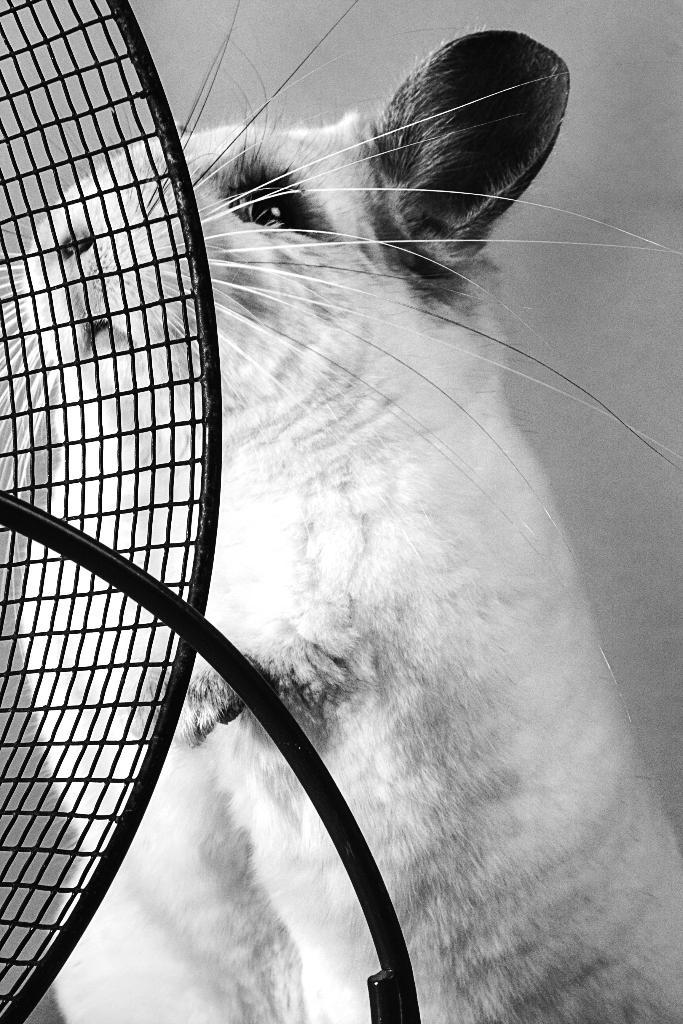What type of animal is in the image? There is an animal in the image, but the specific type cannot be determined from the provided facts. What is the metal object in front of the animal? The metal object in front of the animal cannot be described in detail based on the provided facts. What is the wall behind the animal made of? The wall behind the animal is made of an unspecified material, as the provided facts only mention that it is a wall. What type of plants are growing on the appliance in the image? There is no appliance or plants present in the image. 